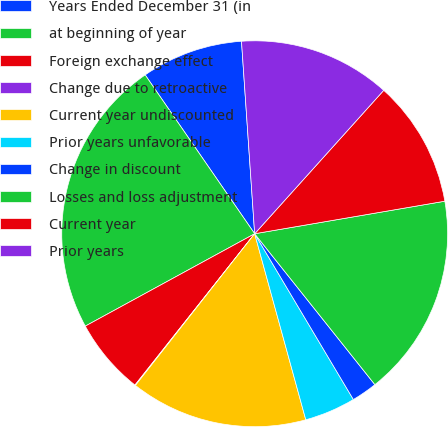Convert chart. <chart><loc_0><loc_0><loc_500><loc_500><pie_chart><fcel>Years Ended December 31 (in<fcel>at beginning of year<fcel>Foreign exchange effect<fcel>Change due to retroactive<fcel>Current year undiscounted<fcel>Prior years unfavorable<fcel>Change in discount<fcel>Losses and loss adjustment<fcel>Current year<fcel>Prior years<nl><fcel>8.52%<fcel>23.34%<fcel>6.4%<fcel>0.05%<fcel>14.87%<fcel>4.28%<fcel>2.16%<fcel>16.99%<fcel>10.64%<fcel>12.75%<nl></chart> 